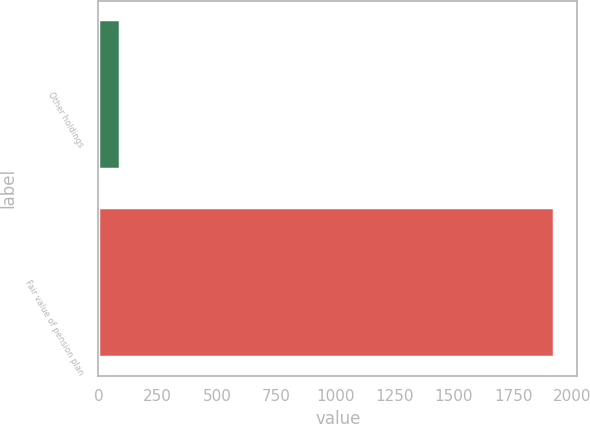Convert chart. <chart><loc_0><loc_0><loc_500><loc_500><bar_chart><fcel>Other holdings<fcel>Fair value of pension plan<nl><fcel>90<fcel>1923<nl></chart> 